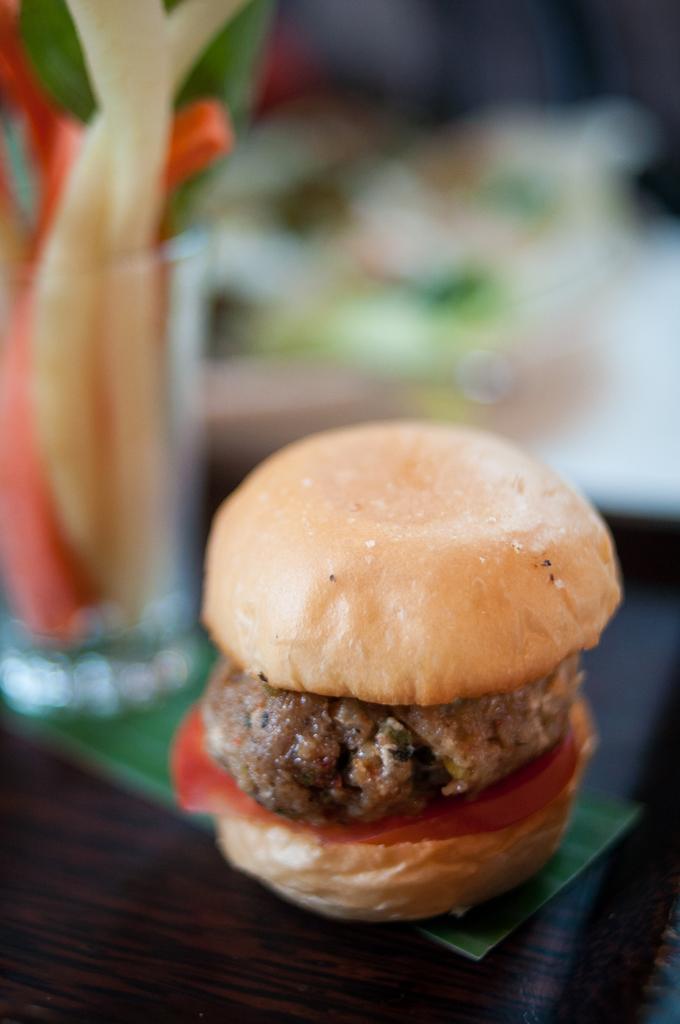In one or two sentences, can you explain what this image depicts? This is a zoomed in picture. In the foreground there is a wooden table on the top of which a glass and a burger is placed. The background of the image is very blurry. 